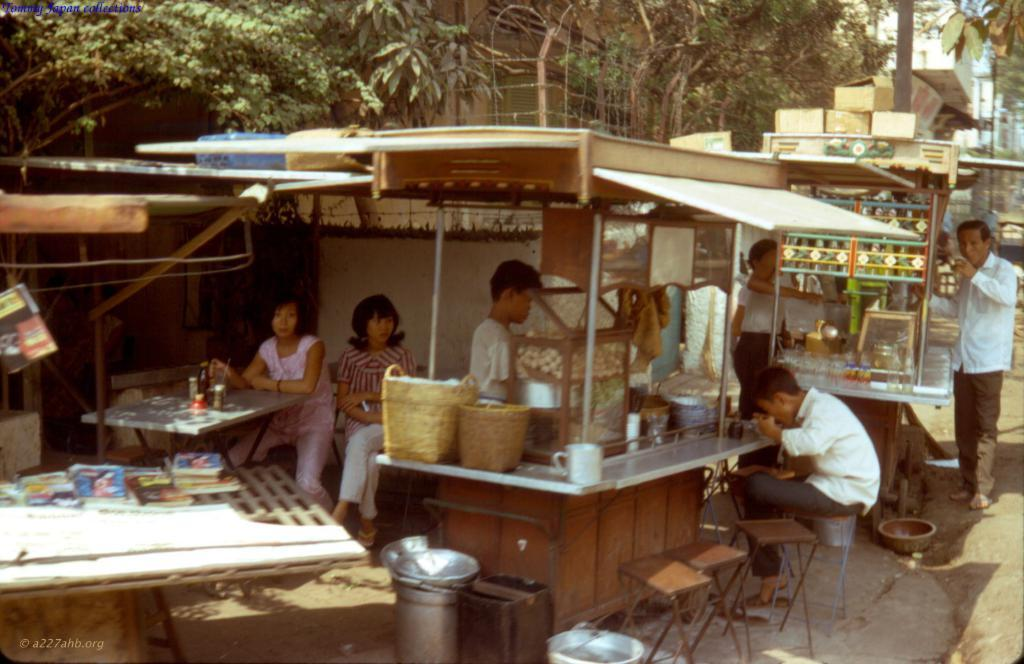How many people are in the image? There is a group of people in the image, but the exact number is not specified. What are the people in the image doing? Some people are sitting, while others are standing. What can be seen on the table in the background? There is a bottle on a table in the background. What is visible in the background of the image? There is a tree and a building visible in the background. What type of flowers are being used as a garnish on the food in the image? There is no food or flowers present in the image; it features a group of people with some sitting and others standing, along with a bottle on a table and a tree and building in the background. 